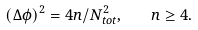Convert formula to latex. <formula><loc_0><loc_0><loc_500><loc_500>( \Delta \phi ) ^ { 2 } = 4 n / N _ { t o t } ^ { 2 } , \quad n \geq 4 .</formula> 